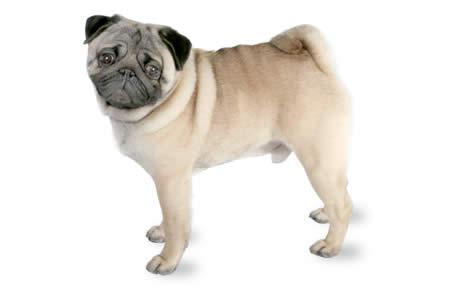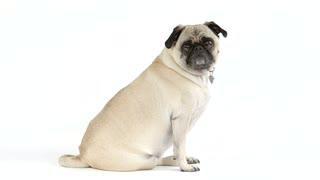The first image is the image on the left, the second image is the image on the right. Considering the images on both sides, is "In one of the images, a dog is sitting down" valid? Answer yes or no. Yes. 